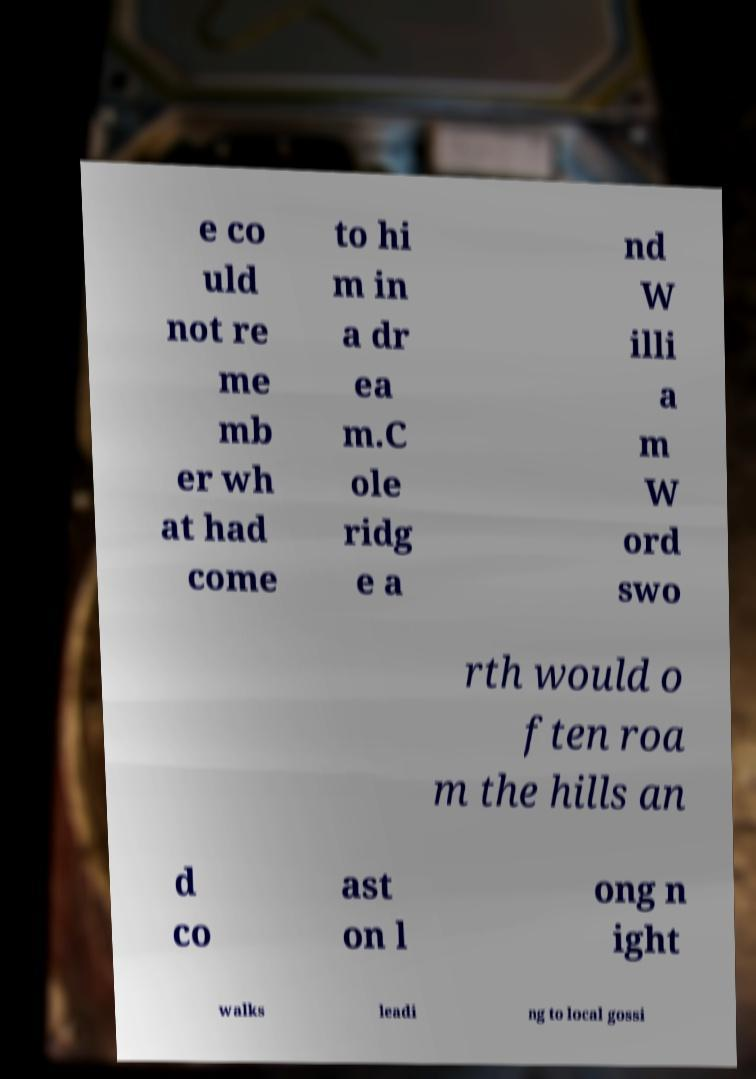I need the written content from this picture converted into text. Can you do that? e co uld not re me mb er wh at had come to hi m in a dr ea m.C ole ridg e a nd W illi a m W ord swo rth would o ften roa m the hills an d co ast on l ong n ight walks leadi ng to local gossi 